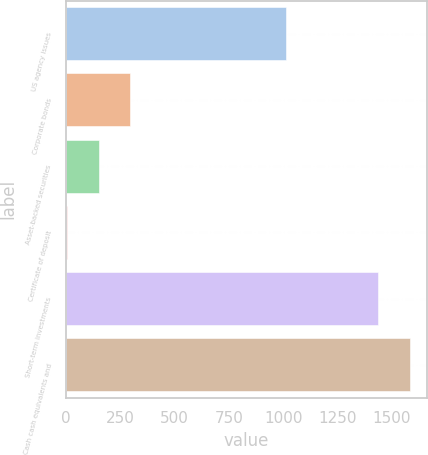Convert chart to OTSL. <chart><loc_0><loc_0><loc_500><loc_500><bar_chart><fcel>US agency issues<fcel>Corporate bonds<fcel>Asset-backed securities<fcel>Certificate of deposit<fcel>Short-term investments<fcel>Cash cash equivalents and<nl><fcel>1011<fcel>296.2<fcel>149.6<fcel>3<fcel>1435<fcel>1581.6<nl></chart> 